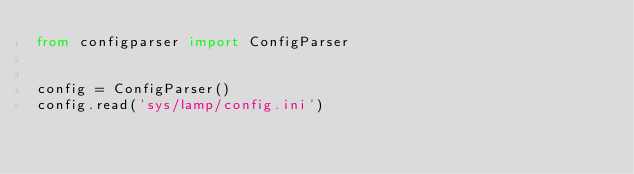<code> <loc_0><loc_0><loc_500><loc_500><_Python_>from configparser import ConfigParser


config = ConfigParser()
config.read('sys/lamp/config.ini')
</code> 